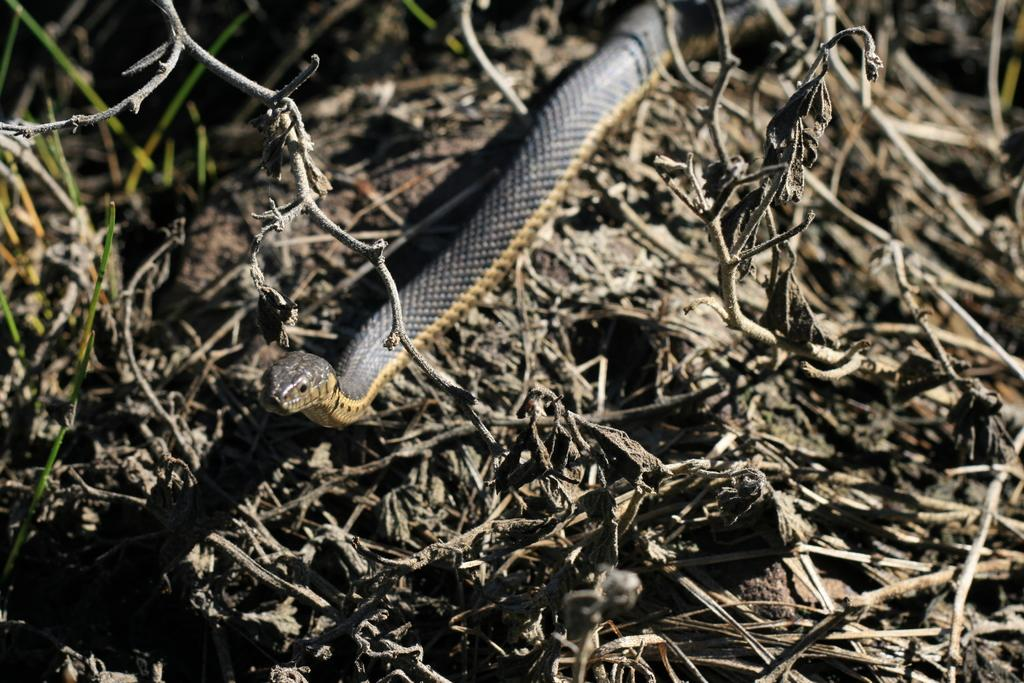What animal is present in the image? There is a snake in the image. What colors can be seen on the snake? The snake is black and cream in color. Where is the snake located in the image? The snake is on the ground. What type of vegetation is present on the ground in the image? There is grass on the ground in the image. What colors can be seen on the grass? The grass is green and brown in color. What type of appliance can be seen in the image? There is no appliance present in the image; it features a snake on the ground with green and brown grass. 